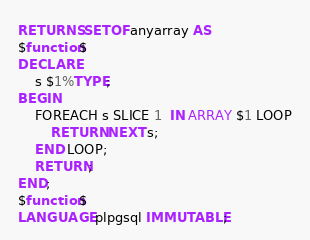<code> <loc_0><loc_0><loc_500><loc_500><_SQL_>RETURNS SETOF anyarray AS
$function$
DECLARE
    s $1%TYPE;
BEGIN
    FOREACH s SLICE 1  IN ARRAY $1 LOOP
        RETURN NEXT s;
    END LOOP;
    RETURN;
END;
$function$
LANGUAGE plpgsql IMMUTABLE;
</code> 